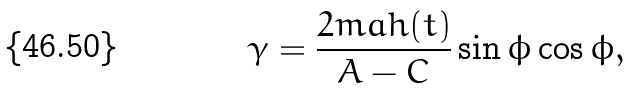Convert formula to latex. <formula><loc_0><loc_0><loc_500><loc_500>\gamma = \frac { 2 m a h ( t ) } { A - C } \sin \phi \cos \phi ,</formula> 